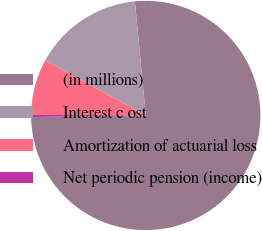<chart> <loc_0><loc_0><loc_500><loc_500><pie_chart><fcel>(in millions)<fcel>Interest c ost<fcel>Amortization of actuarial loss<fcel>Net periodic pension (income)<nl><fcel>76.29%<fcel>15.5%<fcel>7.9%<fcel>0.3%<nl></chart> 